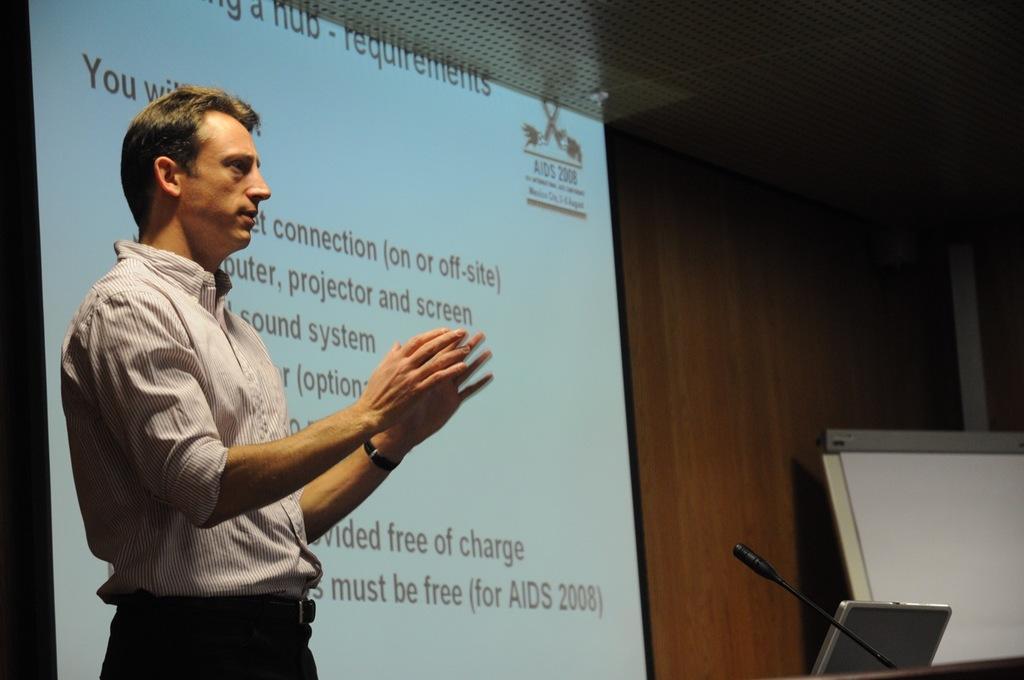Could you give a brief overview of what you see in this image? In the image there is a man he is explaining something and in front of him there is a laptop and a mic, behind him there is a projector screen and something is being displayed on the screen, in the background there is a wooden wall. 